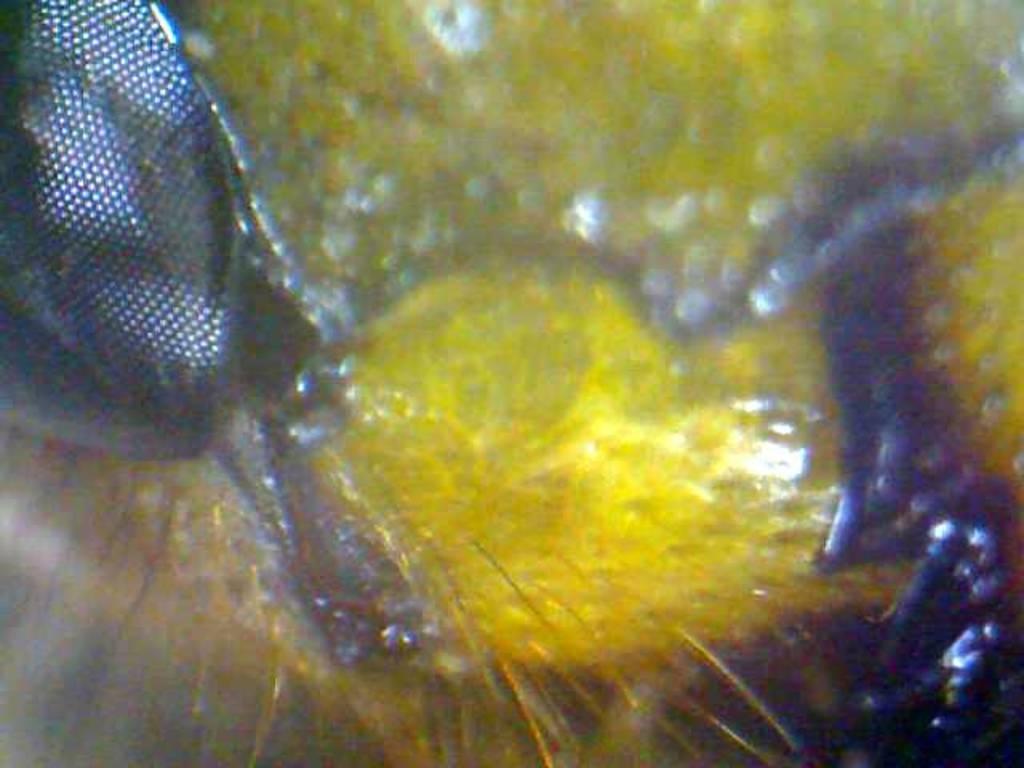Describe this image in one or two sentences. In this zoomed image there are insects. 